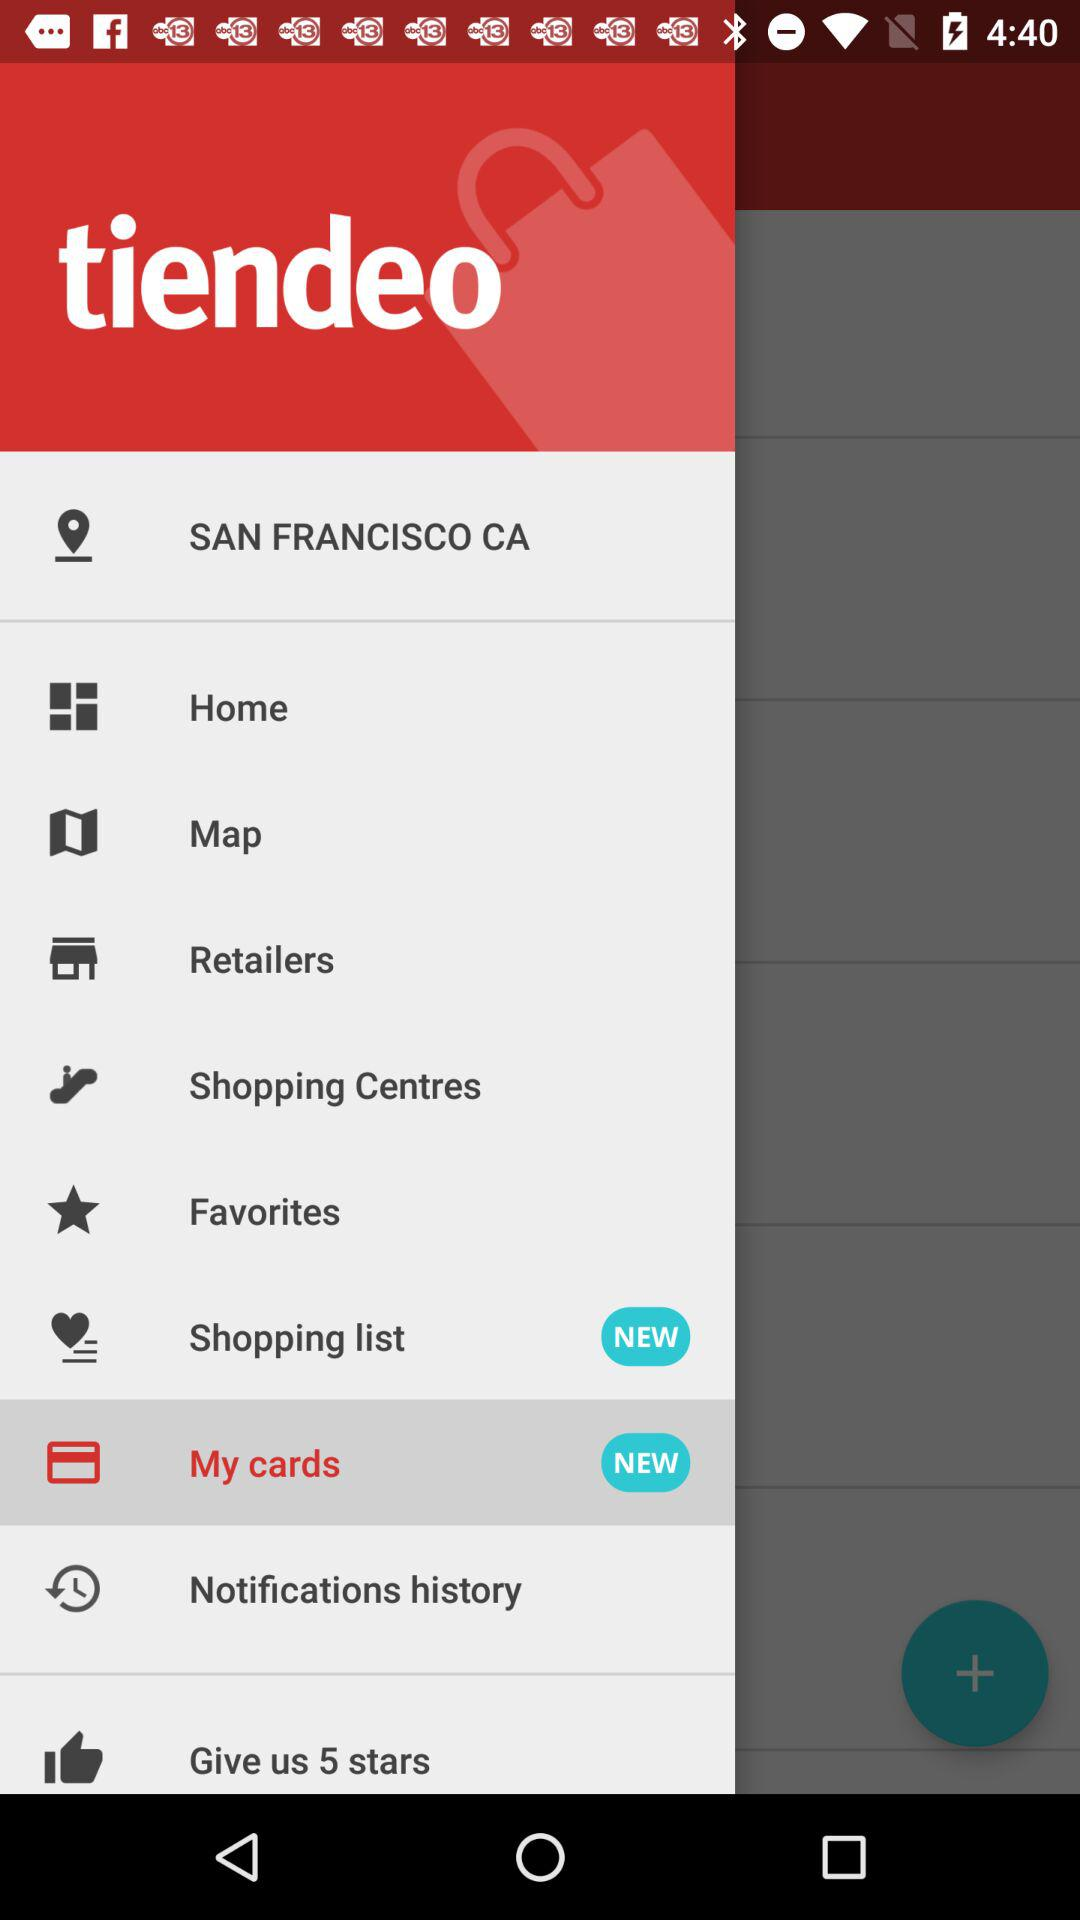What is the application name? The application name is "tiendeo". 